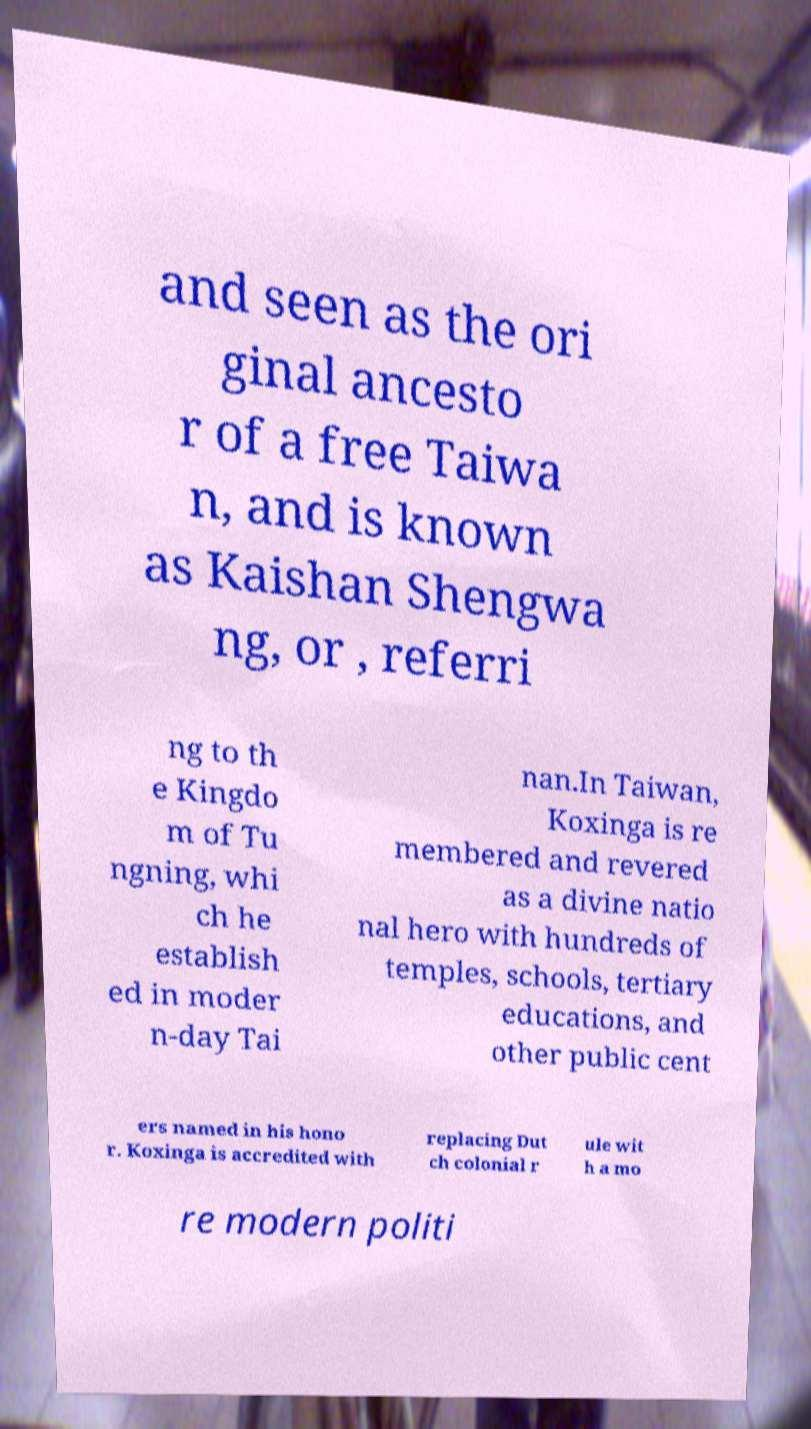There's text embedded in this image that I need extracted. Can you transcribe it verbatim? and seen as the ori ginal ancesto r of a free Taiwa n, and is known as Kaishan Shengwa ng, or , referri ng to th e Kingdo m of Tu ngning, whi ch he establish ed in moder n-day Tai nan.In Taiwan, Koxinga is re membered and revered as a divine natio nal hero with hundreds of temples, schools, tertiary educations, and other public cent ers named in his hono r. Koxinga is accredited with replacing Dut ch colonial r ule wit h a mo re modern politi 